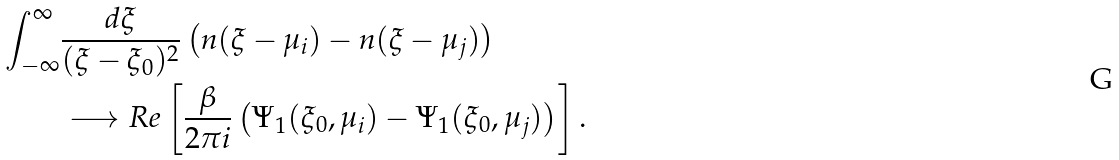<formula> <loc_0><loc_0><loc_500><loc_500>\int _ { - \infty } ^ { \infty } & \frac { d \xi } { ( \xi - \xi _ { 0 } ) ^ { 2 } } \left ( n ( \xi - \mu _ { i } ) - n ( \xi - \mu _ { j } ) \right ) \\ & \longrightarrow R e \left [ \frac { \beta } { 2 \pi i } \left ( \Psi _ { 1 } ( \xi _ { 0 } , \mu _ { i } ) - \Psi _ { 1 } ( \xi _ { 0 } , \mu _ { j } ) \right ) \right ] .</formula> 